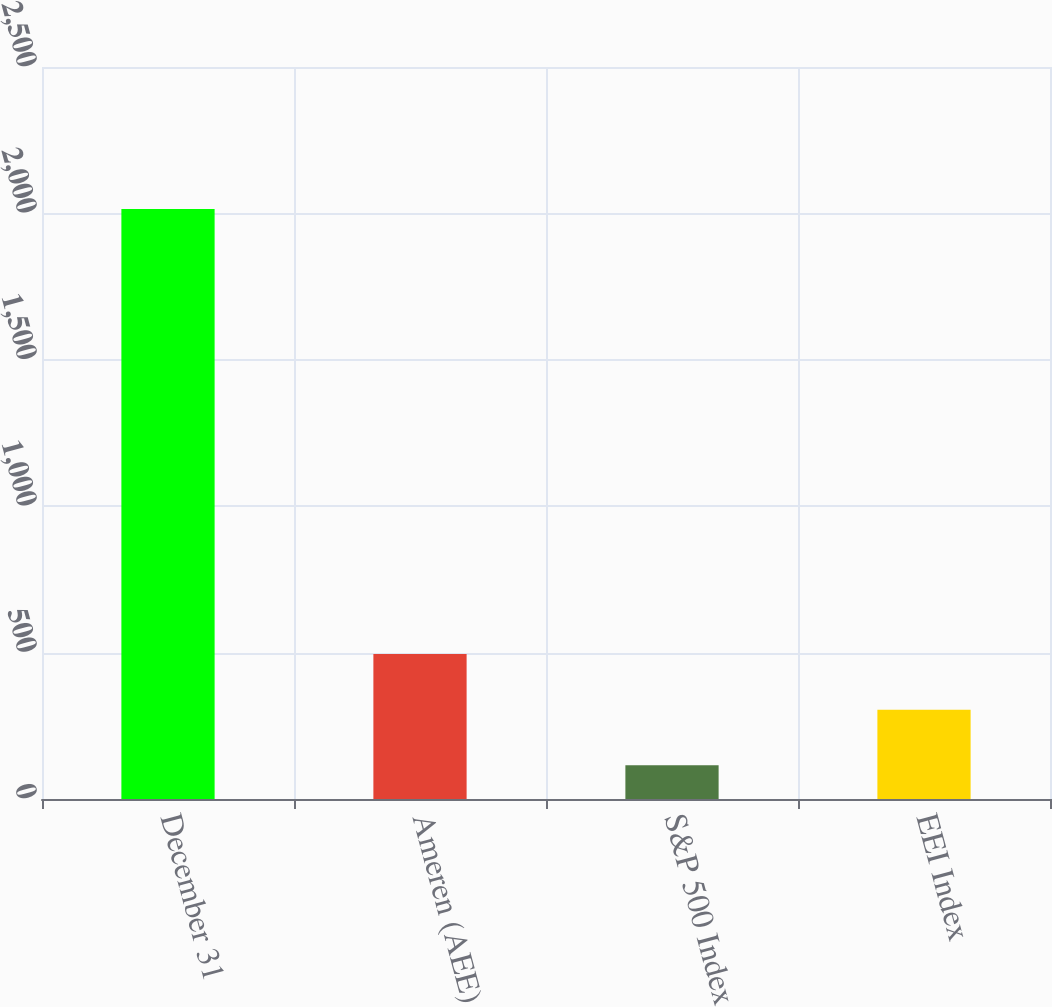Convert chart. <chart><loc_0><loc_0><loc_500><loc_500><bar_chart><fcel>December 31<fcel>Ameren (AEE)<fcel>S&P 500 Index<fcel>EEI Index<nl><fcel>2015<fcel>495.2<fcel>115.26<fcel>305.23<nl></chart> 